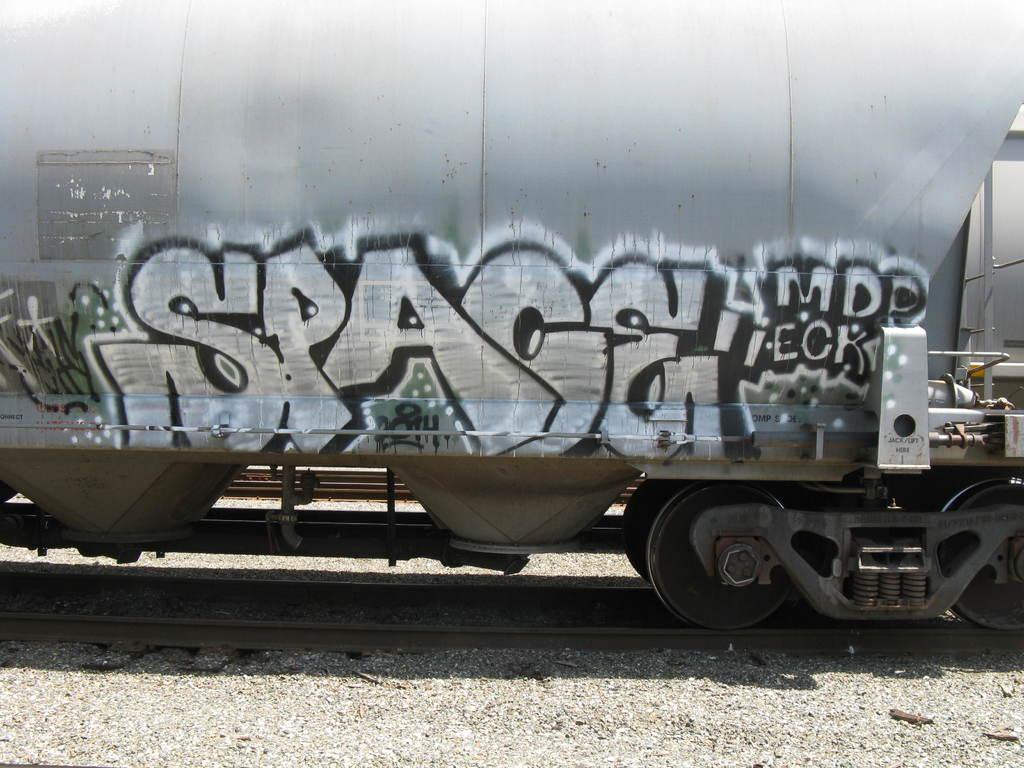How would you summarize this image in a sentence or two? In this image there is graffiti on the train which is on the railway tracks. 